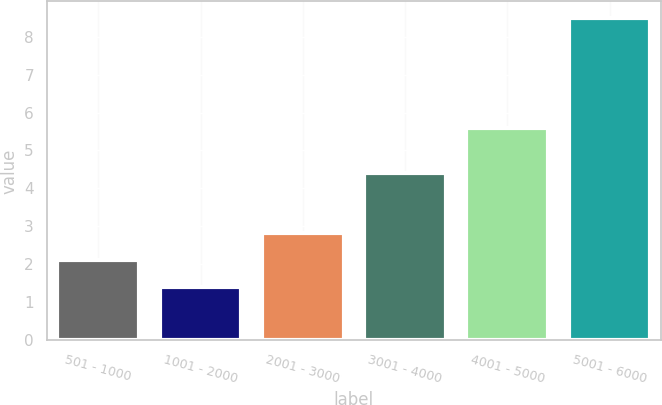<chart> <loc_0><loc_0><loc_500><loc_500><bar_chart><fcel>501 - 1000<fcel>1001 - 2000<fcel>2001 - 3000<fcel>3001 - 4000<fcel>4001 - 5000<fcel>5001 - 6000<nl><fcel>2.11<fcel>1.4<fcel>2.82<fcel>4.4<fcel>5.6<fcel>8.5<nl></chart> 